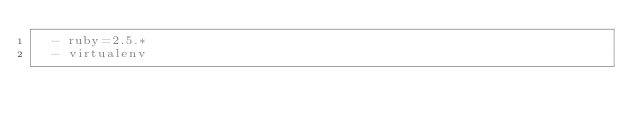<code> <loc_0><loc_0><loc_500><loc_500><_YAML_>  - ruby=2.5.*
  - virtualenv</code> 